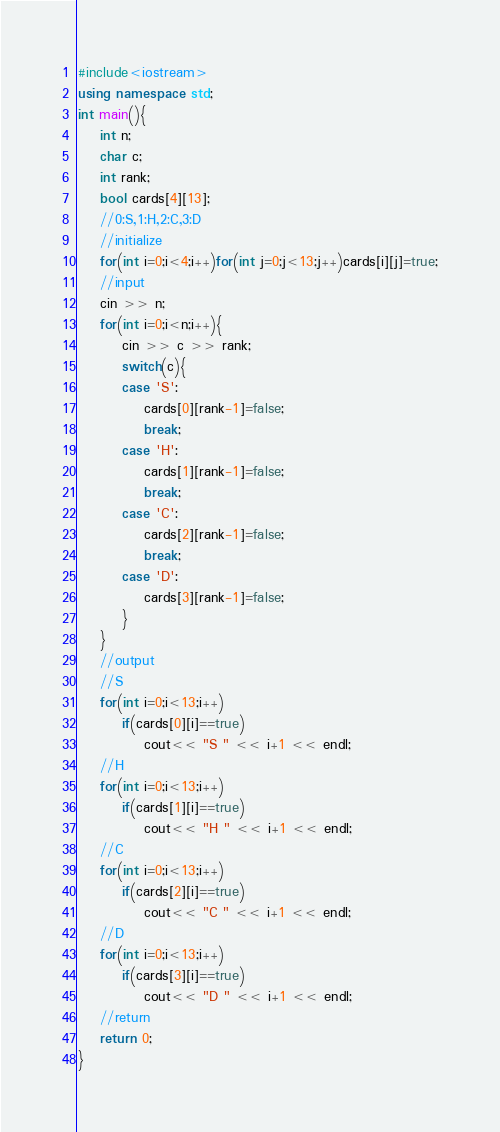Convert code to text. <code><loc_0><loc_0><loc_500><loc_500><_C++_>#include<iostream>
using namespace std;
int main(){
	int n;
	char c;
	int rank;
	bool cards[4][13];
	//0:S,1:H,2:C,3:D
	//initialize
	for(int i=0;i<4;i++)for(int j=0;j<13;j++)cards[i][j]=true;
	//input
	cin >> n;
	for(int i=0;i<n;i++){
		cin >> c >> rank;
		switch(c){
		case 'S':
			cards[0][rank-1]=false;
			break;
		case 'H':
			cards[1][rank-1]=false;
			break;
		case 'C':
			cards[2][rank-1]=false;
			break;
		case 'D':
			cards[3][rank-1]=false;
		}
	}
	//output
	//S
	for(int i=0;i<13;i++)
		if(cards[0][i]==true)
			cout<< "S " << i+1 << endl;
	//H
	for(int i=0;i<13;i++)
		if(cards[1][i]==true)
			cout<< "H " << i+1 << endl;
	//C
	for(int i=0;i<13;i++)
		if(cards[2][i]==true)
			cout<< "C " << i+1 << endl;
	//D
	for(int i=0;i<13;i++)
		if(cards[3][i]==true)
			cout<< "D " << i+1 << endl;
	//return
	return 0;
}</code> 